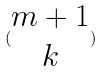Convert formula to latex. <formula><loc_0><loc_0><loc_500><loc_500>( \begin{matrix} m + 1 \\ k \end{matrix} )</formula> 